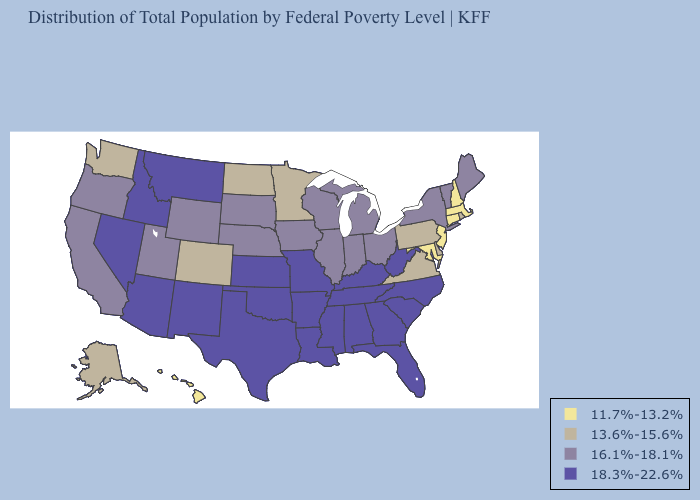What is the lowest value in the Northeast?
Concise answer only. 11.7%-13.2%. Does Nevada have a higher value than Florida?
Keep it brief. No. What is the value of Wisconsin?
Keep it brief. 16.1%-18.1%. Name the states that have a value in the range 18.3%-22.6%?
Keep it brief. Alabama, Arizona, Arkansas, Florida, Georgia, Idaho, Kansas, Kentucky, Louisiana, Mississippi, Missouri, Montana, Nevada, New Mexico, North Carolina, Oklahoma, South Carolina, Tennessee, Texas, West Virginia. Name the states that have a value in the range 11.7%-13.2%?
Quick response, please. Connecticut, Hawaii, Maryland, Massachusetts, New Hampshire, New Jersey. What is the value of Iowa?
Give a very brief answer. 16.1%-18.1%. Name the states that have a value in the range 13.6%-15.6%?
Write a very short answer. Alaska, Colorado, Delaware, Minnesota, North Dakota, Pennsylvania, Rhode Island, Virginia, Washington. What is the value of Montana?
Write a very short answer. 18.3%-22.6%. Does the map have missing data?
Quick response, please. No. Does Virginia have a higher value than New Jersey?
Write a very short answer. Yes. Does the first symbol in the legend represent the smallest category?
Be succinct. Yes. What is the lowest value in the MidWest?
Be succinct. 13.6%-15.6%. Name the states that have a value in the range 18.3%-22.6%?
Answer briefly. Alabama, Arizona, Arkansas, Florida, Georgia, Idaho, Kansas, Kentucky, Louisiana, Mississippi, Missouri, Montana, Nevada, New Mexico, North Carolina, Oklahoma, South Carolina, Tennessee, Texas, West Virginia. What is the value of Louisiana?
Concise answer only. 18.3%-22.6%. What is the value of West Virginia?
Answer briefly. 18.3%-22.6%. 